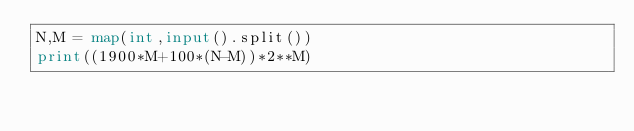Convert code to text. <code><loc_0><loc_0><loc_500><loc_500><_Python_>N,M = map(int,input().split())
print((1900*M+100*(N-M))*2**M)
</code> 